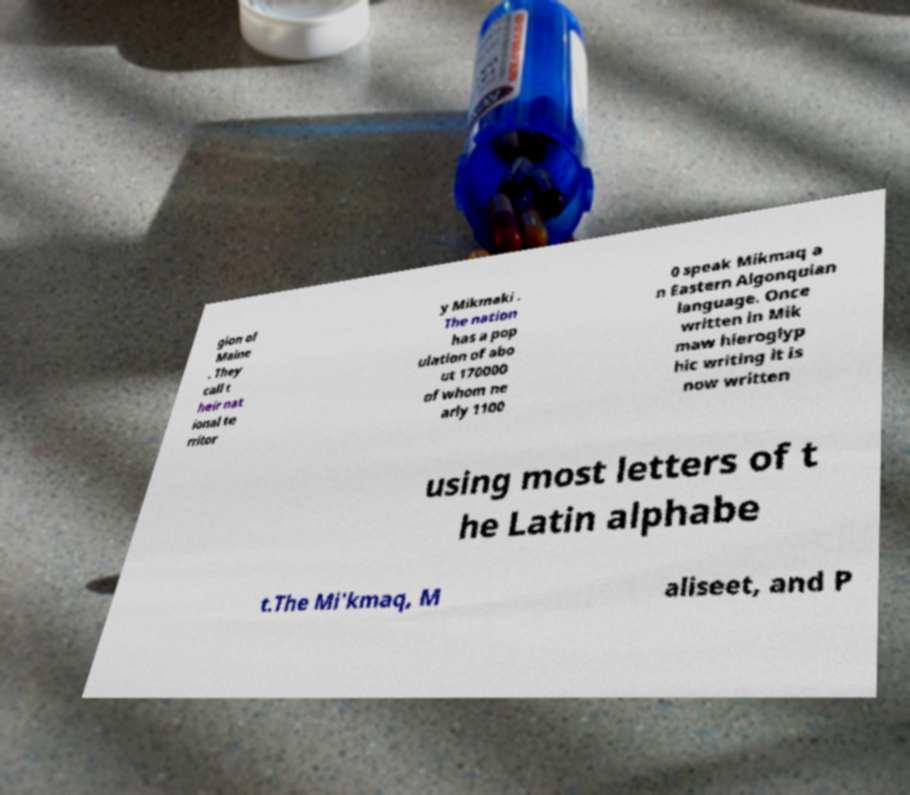Could you assist in decoding the text presented in this image and type it out clearly? gion of Maine . They call t heir nat ional te rritor y Mikmaki . The nation has a pop ulation of abo ut 170000 of whom ne arly 1100 0 speak Mikmaq a n Eastern Algonquian language. Once written in Mik maw hieroglyp hic writing it is now written using most letters of t he Latin alphabe t.The Mi'kmaq, M aliseet, and P 